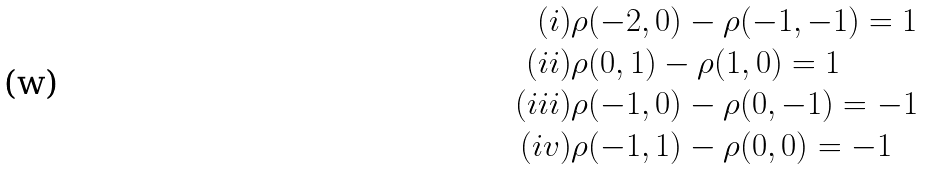<formula> <loc_0><loc_0><loc_500><loc_500>( i ) & \rho ( - 2 , 0 ) - \rho ( - 1 , - 1 ) = 1 \\ ( i i ) & \rho ( 0 , 1 ) - \rho ( 1 , 0 ) = 1 \\ ( i i i ) & \rho ( - 1 , 0 ) - \rho ( 0 , - 1 ) = - 1 \\ ( i v ) & \rho ( - 1 , 1 ) - \rho ( 0 , 0 ) = - 1 \\</formula> 